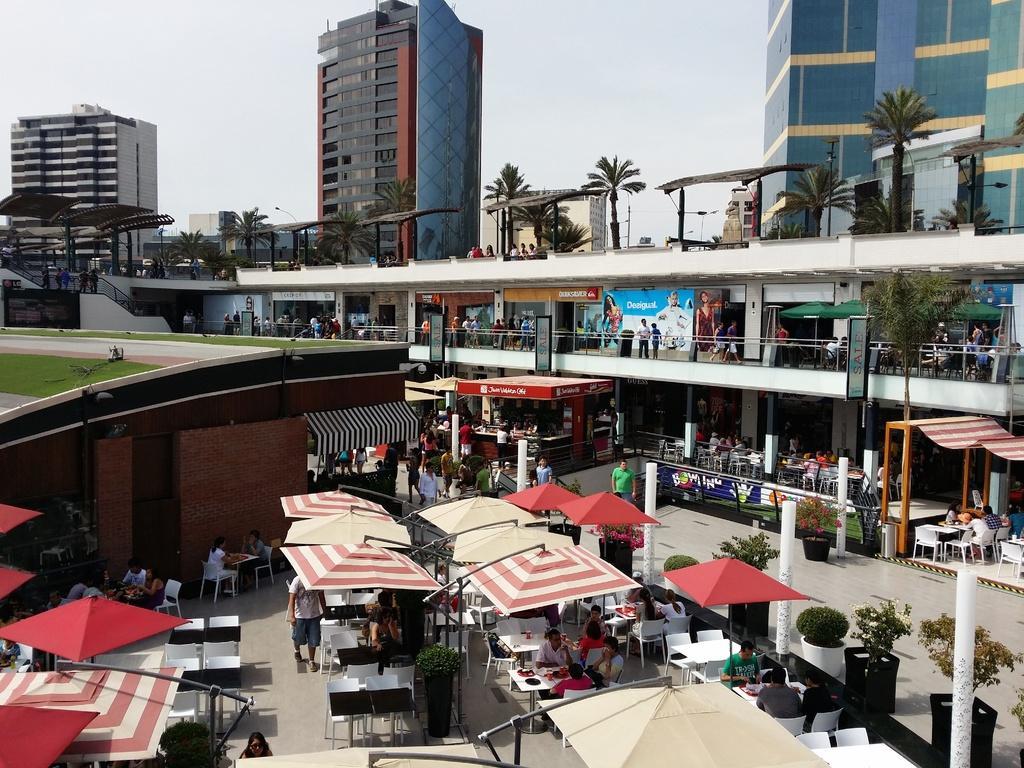Please provide a concise description of this image. In this image, we can see some buildings, tents and trees. There are some people standing and some people sitting on the chairs. We can see the sky. 